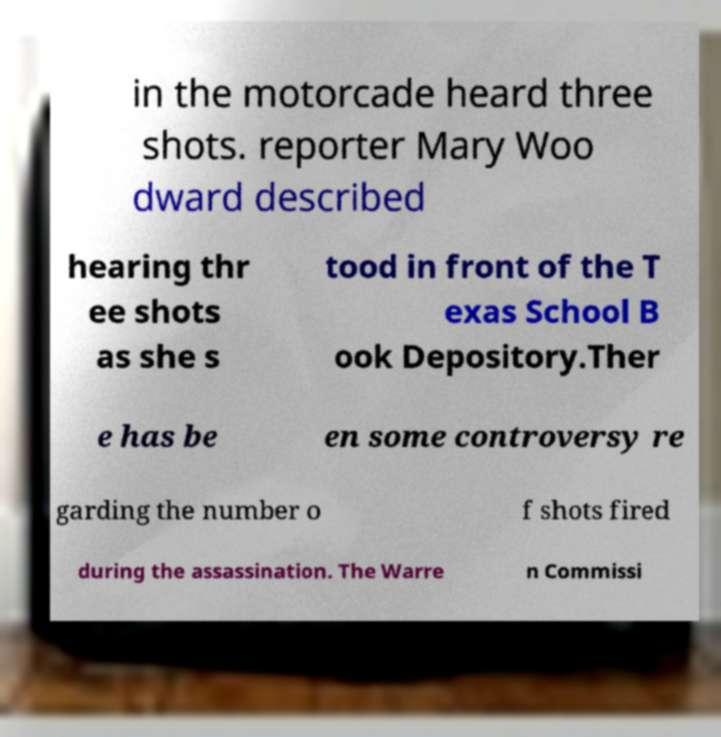Please read and relay the text visible in this image. What does it say? in the motorcade heard three shots. reporter Mary Woo dward described hearing thr ee shots as she s tood in front of the T exas School B ook Depository.Ther e has be en some controversy re garding the number o f shots fired during the assassination. The Warre n Commissi 